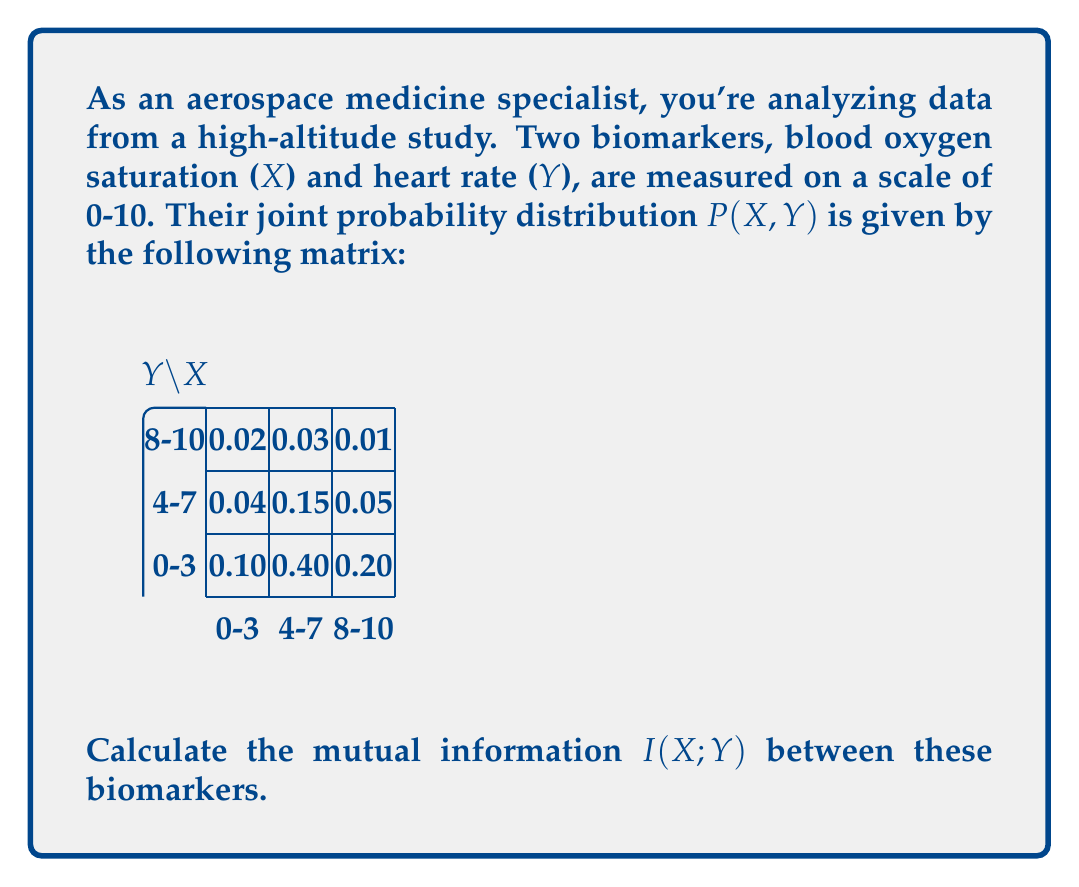Can you solve this math problem? To calculate the mutual information I(X;Y), we'll follow these steps:

1) First, calculate the marginal probabilities P(X) and P(Y):

   P(X=0-3) = 0.02 + 0.04 + 0.10 = 0.16
   P(X=4-7) = 0.03 + 0.15 + 0.40 = 0.58
   P(X=8-10) = 0.01 + 0.05 + 0.20 = 0.26

   P(Y=0-3) = 0.02 + 0.03 + 0.01 = 0.06
   P(Y=4-7) = 0.04 + 0.15 + 0.05 = 0.24
   P(Y=8-10) = 0.10 + 0.40 + 0.20 = 0.70

2) The mutual information is given by:

   $$I(X;Y) = \sum_{x}\sum_{y} P(x,y) \log_2 \frac{P(x,y)}{P(x)P(y)}$$

3) Calculate each term:

   0.02 * log2(0.02 / (0.16 * 0.06)) = 0.0270
   0.03 * log2(0.03 / (0.58 * 0.06)) = 0.0280
   0.01 * log2(0.01 / (0.26 * 0.06)) = 0.0101
   0.04 * log2(0.04 / (0.16 * 0.24)) = 0.0456
   0.15 * log2(0.15 / (0.58 * 0.24)) = 0.0603
   0.05 * log2(0.05 / (0.26 * 0.24)) = 0.0246
   0.10 * log2(0.10 / (0.16 * 0.70)) = 0.0897
   0.40 * log2(0.40 / (0.58 * 0.70)) = 0.0893
   0.20 * log2(0.20 / (0.26 * 0.70)) = 0.0799

4) Sum all terms:

   I(X;Y) = 0.0270 + 0.0280 + 0.0101 + 0.0456 + 0.0603 + 0.0246 + 0.0897 + 0.0893 + 0.0799 = 0.4545

Therefore, the mutual information I(X;Y) is approximately 0.4545 bits.
Answer: 0.4545 bits 